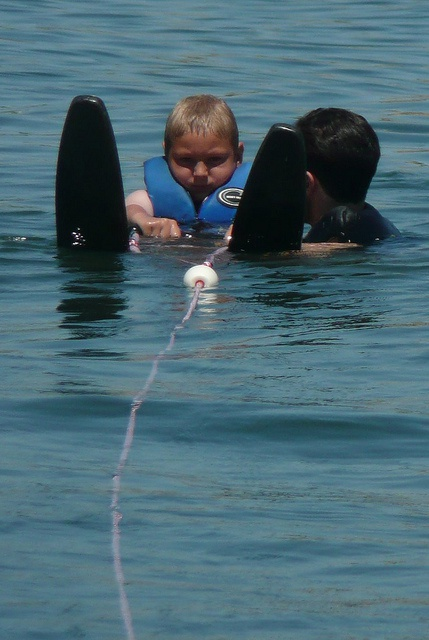Describe the objects in this image and their specific colors. I can see skis in teal, black, gray, and blue tones, people in teal, black, gray, and blue tones, and people in teal, gray, black, and maroon tones in this image. 